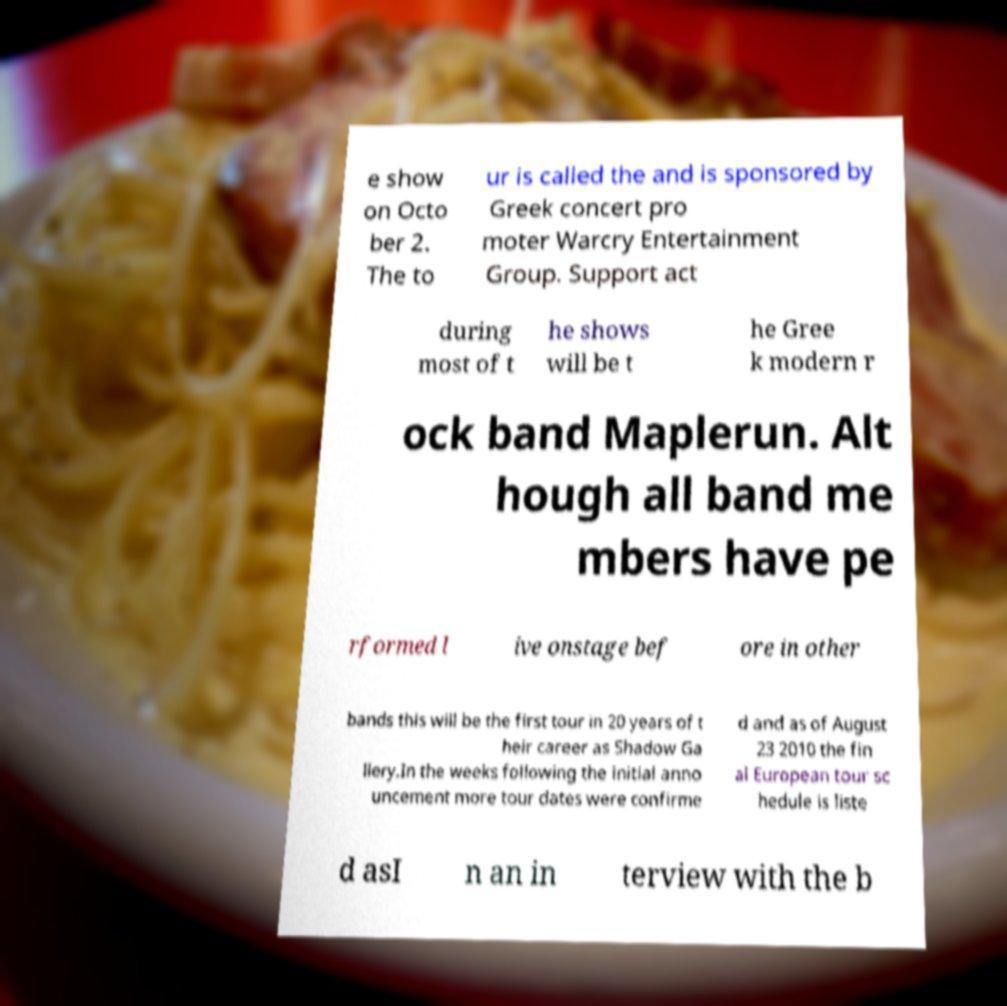I need the written content from this picture converted into text. Can you do that? e show on Octo ber 2. The to ur is called the and is sponsored by Greek concert pro moter Warcry Entertainment Group. Support act during most of t he shows will be t he Gree k modern r ock band Maplerun. Alt hough all band me mbers have pe rformed l ive onstage bef ore in other bands this will be the first tour in 20 years of t heir career as Shadow Ga llery.In the weeks following the initial anno uncement more tour dates were confirme d and as of August 23 2010 the fin al European tour sc hedule is liste d asI n an in terview with the b 